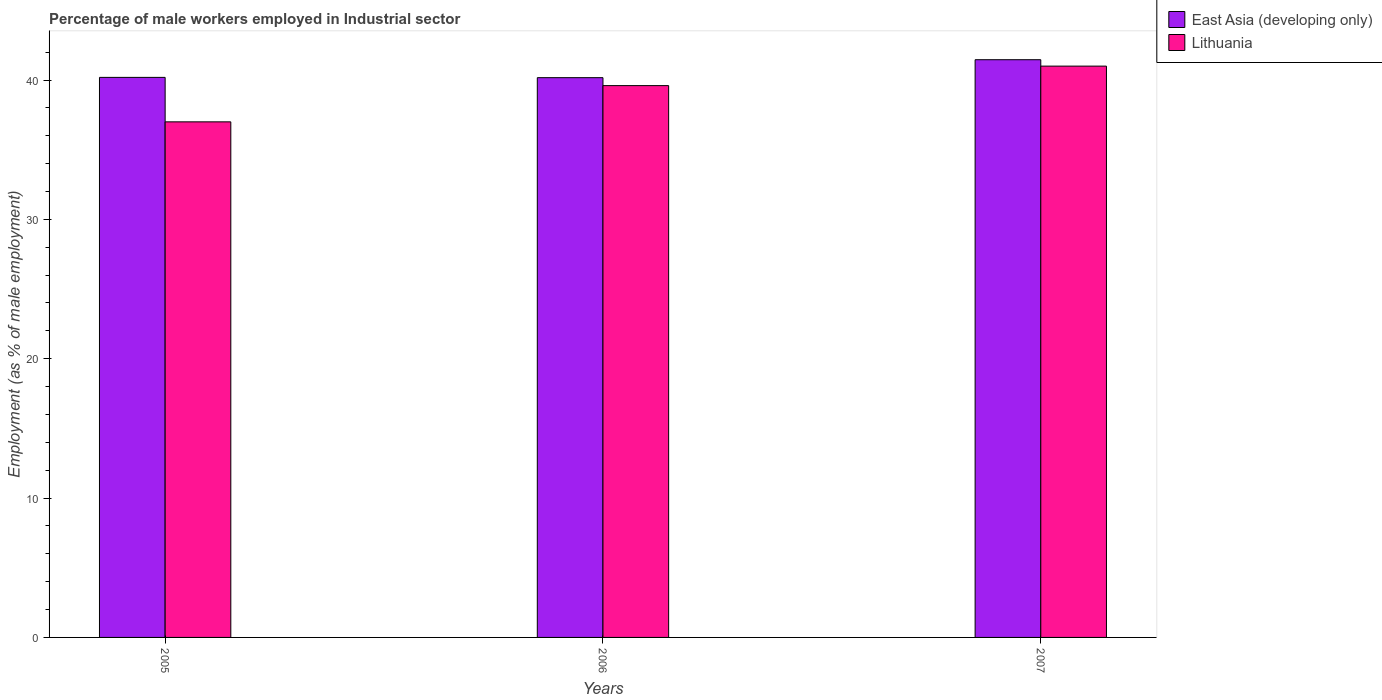Are the number of bars per tick equal to the number of legend labels?
Your answer should be very brief. Yes. Are the number of bars on each tick of the X-axis equal?
Provide a short and direct response. Yes. How many bars are there on the 2nd tick from the left?
Keep it short and to the point. 2. What is the label of the 1st group of bars from the left?
Give a very brief answer. 2005. In how many cases, is the number of bars for a given year not equal to the number of legend labels?
Your answer should be compact. 0. What is the percentage of male workers employed in Industrial sector in Lithuania in 2006?
Your answer should be compact. 39.6. Across all years, what is the maximum percentage of male workers employed in Industrial sector in East Asia (developing only)?
Ensure brevity in your answer.  41.46. In which year was the percentage of male workers employed in Industrial sector in East Asia (developing only) minimum?
Your answer should be very brief. 2006. What is the total percentage of male workers employed in Industrial sector in East Asia (developing only) in the graph?
Offer a terse response. 121.82. What is the difference between the percentage of male workers employed in Industrial sector in East Asia (developing only) in 2007 and the percentage of male workers employed in Industrial sector in Lithuania in 2006?
Your response must be concise. 1.86. What is the average percentage of male workers employed in Industrial sector in East Asia (developing only) per year?
Keep it short and to the point. 40.61. In the year 2005, what is the difference between the percentage of male workers employed in Industrial sector in East Asia (developing only) and percentage of male workers employed in Industrial sector in Lithuania?
Your response must be concise. 3.19. What is the ratio of the percentage of male workers employed in Industrial sector in East Asia (developing only) in 2005 to that in 2007?
Ensure brevity in your answer.  0.97. What is the difference between the highest and the second highest percentage of male workers employed in Industrial sector in Lithuania?
Your answer should be very brief. 1.4. What is the difference between the highest and the lowest percentage of male workers employed in Industrial sector in East Asia (developing only)?
Provide a succinct answer. 1.29. Is the sum of the percentage of male workers employed in Industrial sector in Lithuania in 2005 and 2006 greater than the maximum percentage of male workers employed in Industrial sector in East Asia (developing only) across all years?
Your answer should be very brief. Yes. What does the 2nd bar from the left in 2006 represents?
Provide a succinct answer. Lithuania. What does the 2nd bar from the right in 2007 represents?
Provide a succinct answer. East Asia (developing only). How many bars are there?
Your response must be concise. 6. Are all the bars in the graph horizontal?
Offer a very short reply. No. Are the values on the major ticks of Y-axis written in scientific E-notation?
Your answer should be very brief. No. Where does the legend appear in the graph?
Offer a very short reply. Top right. How are the legend labels stacked?
Offer a very short reply. Vertical. What is the title of the graph?
Ensure brevity in your answer.  Percentage of male workers employed in Industrial sector. Does "Antigua and Barbuda" appear as one of the legend labels in the graph?
Your response must be concise. No. What is the label or title of the X-axis?
Your answer should be compact. Years. What is the label or title of the Y-axis?
Your answer should be compact. Employment (as % of male employment). What is the Employment (as % of male employment) in East Asia (developing only) in 2005?
Make the answer very short. 40.19. What is the Employment (as % of male employment) of Lithuania in 2005?
Keep it short and to the point. 37. What is the Employment (as % of male employment) in East Asia (developing only) in 2006?
Your answer should be compact. 40.17. What is the Employment (as % of male employment) of Lithuania in 2006?
Offer a very short reply. 39.6. What is the Employment (as % of male employment) of East Asia (developing only) in 2007?
Keep it short and to the point. 41.46. Across all years, what is the maximum Employment (as % of male employment) of East Asia (developing only)?
Your response must be concise. 41.46. Across all years, what is the maximum Employment (as % of male employment) in Lithuania?
Your answer should be very brief. 41. Across all years, what is the minimum Employment (as % of male employment) of East Asia (developing only)?
Offer a very short reply. 40.17. Across all years, what is the minimum Employment (as % of male employment) in Lithuania?
Offer a terse response. 37. What is the total Employment (as % of male employment) of East Asia (developing only) in the graph?
Give a very brief answer. 121.82. What is the total Employment (as % of male employment) of Lithuania in the graph?
Your answer should be very brief. 117.6. What is the difference between the Employment (as % of male employment) in East Asia (developing only) in 2005 and that in 2006?
Provide a succinct answer. 0.02. What is the difference between the Employment (as % of male employment) in East Asia (developing only) in 2005 and that in 2007?
Keep it short and to the point. -1.27. What is the difference between the Employment (as % of male employment) of East Asia (developing only) in 2006 and that in 2007?
Keep it short and to the point. -1.29. What is the difference between the Employment (as % of male employment) of East Asia (developing only) in 2005 and the Employment (as % of male employment) of Lithuania in 2006?
Provide a short and direct response. 0.59. What is the difference between the Employment (as % of male employment) in East Asia (developing only) in 2005 and the Employment (as % of male employment) in Lithuania in 2007?
Ensure brevity in your answer.  -0.81. What is the difference between the Employment (as % of male employment) in East Asia (developing only) in 2006 and the Employment (as % of male employment) in Lithuania in 2007?
Ensure brevity in your answer.  -0.83. What is the average Employment (as % of male employment) in East Asia (developing only) per year?
Offer a terse response. 40.61. What is the average Employment (as % of male employment) in Lithuania per year?
Keep it short and to the point. 39.2. In the year 2005, what is the difference between the Employment (as % of male employment) in East Asia (developing only) and Employment (as % of male employment) in Lithuania?
Provide a succinct answer. 3.19. In the year 2006, what is the difference between the Employment (as % of male employment) of East Asia (developing only) and Employment (as % of male employment) of Lithuania?
Provide a succinct answer. 0.57. In the year 2007, what is the difference between the Employment (as % of male employment) of East Asia (developing only) and Employment (as % of male employment) of Lithuania?
Make the answer very short. 0.46. What is the ratio of the Employment (as % of male employment) of Lithuania in 2005 to that in 2006?
Your answer should be compact. 0.93. What is the ratio of the Employment (as % of male employment) of East Asia (developing only) in 2005 to that in 2007?
Provide a succinct answer. 0.97. What is the ratio of the Employment (as % of male employment) of Lithuania in 2005 to that in 2007?
Keep it short and to the point. 0.9. What is the ratio of the Employment (as % of male employment) in East Asia (developing only) in 2006 to that in 2007?
Your answer should be very brief. 0.97. What is the ratio of the Employment (as % of male employment) of Lithuania in 2006 to that in 2007?
Ensure brevity in your answer.  0.97. What is the difference between the highest and the second highest Employment (as % of male employment) in East Asia (developing only)?
Ensure brevity in your answer.  1.27. What is the difference between the highest and the lowest Employment (as % of male employment) in East Asia (developing only)?
Provide a succinct answer. 1.29. What is the difference between the highest and the lowest Employment (as % of male employment) in Lithuania?
Ensure brevity in your answer.  4. 